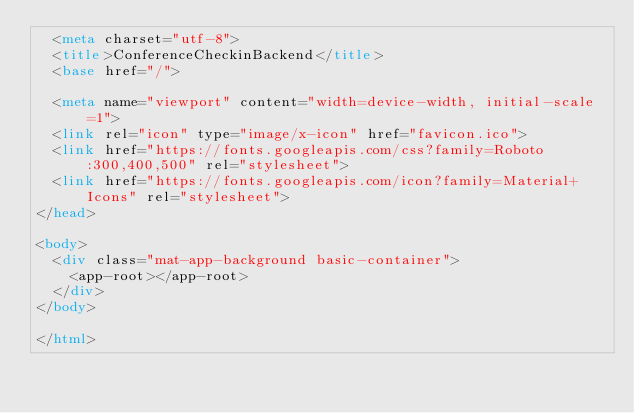Convert code to text. <code><loc_0><loc_0><loc_500><loc_500><_HTML_>  <meta charset="utf-8">
  <title>ConferenceCheckinBackend</title>
  <base href="/">

  <meta name="viewport" content="width=device-width, initial-scale=1">
  <link rel="icon" type="image/x-icon" href="favicon.ico">
  <link href="https://fonts.googleapis.com/css?family=Roboto:300,400,500" rel="stylesheet">
  <link href="https://fonts.googleapis.com/icon?family=Material+Icons" rel="stylesheet">
</head>

<body>
  <div class="mat-app-background basic-container">
    <app-root></app-root>
  </div>
</body>

</html></code> 